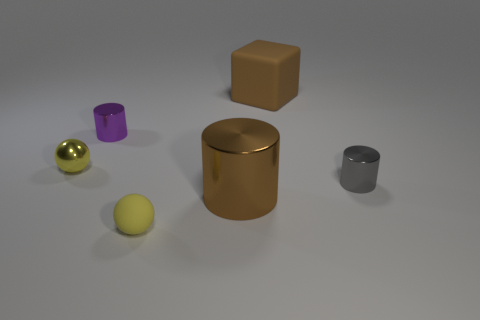What number of other things are there of the same shape as the purple object?
Make the answer very short. 2. What is the size of the object that is both behind the yellow metallic sphere and to the left of the tiny matte sphere?
Give a very brief answer. Small. What number of matte objects are big brown blocks or tiny purple things?
Ensure brevity in your answer.  1. There is a large brown thing that is in front of the metallic sphere; does it have the same shape as the tiny yellow object that is in front of the small gray cylinder?
Your response must be concise. No. Are there any gray cylinders made of the same material as the large block?
Your response must be concise. No. The small shiny sphere has what color?
Ensure brevity in your answer.  Yellow. There is a metal cylinder that is in front of the small gray shiny object; what size is it?
Keep it short and to the point. Large. What number of large objects are the same color as the matte ball?
Give a very brief answer. 0. There is a tiny yellow thing behind the yellow matte thing; is there a large cylinder that is on the right side of it?
Your answer should be very brief. Yes. Do the tiny object that is right of the brown cube and the large object in front of the small purple cylinder have the same color?
Your response must be concise. No. 